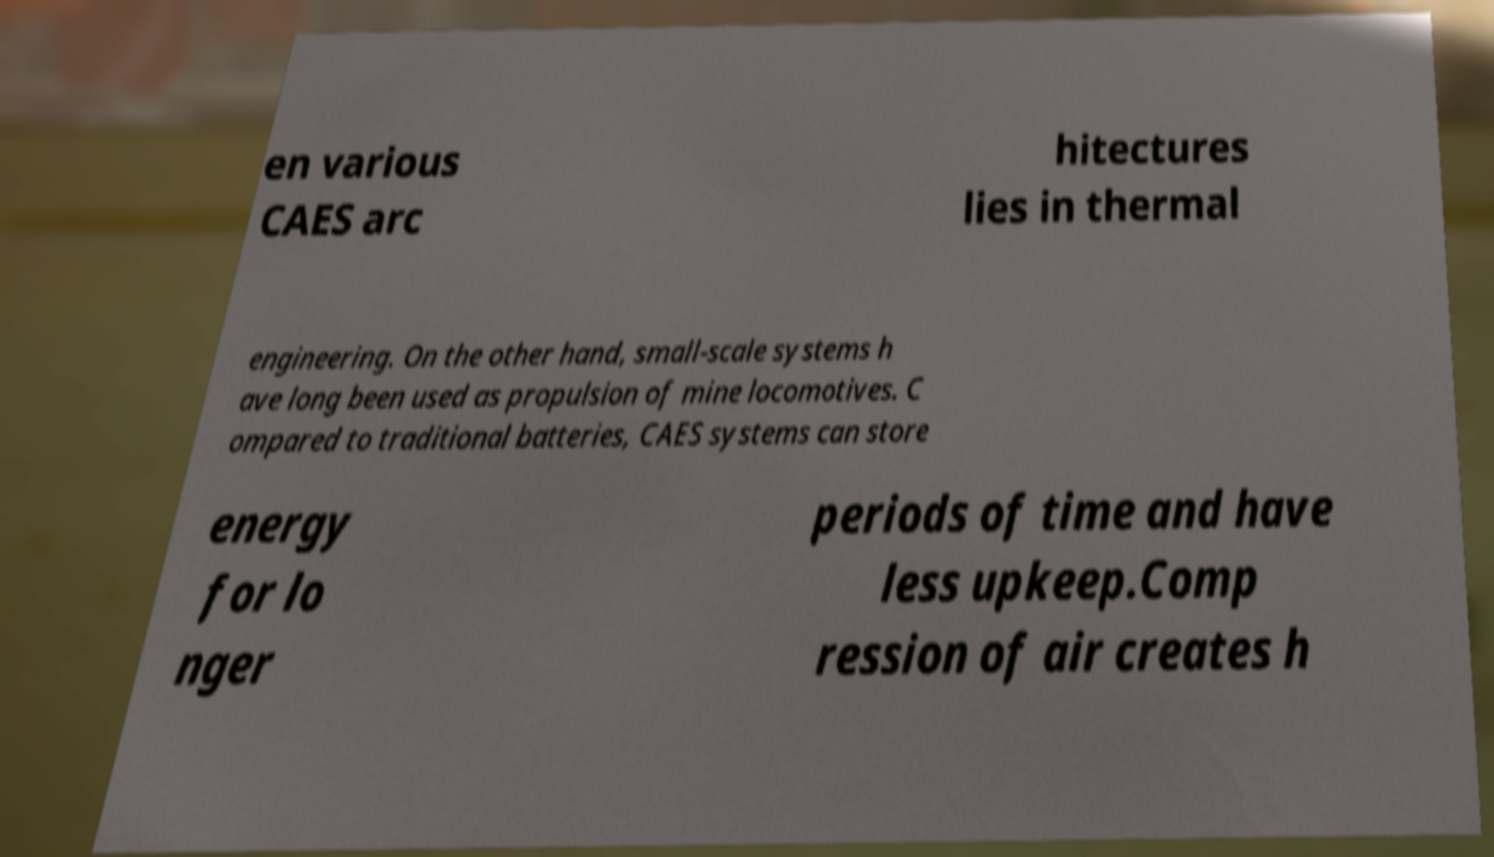Please identify and transcribe the text found in this image. en various CAES arc hitectures lies in thermal engineering. On the other hand, small-scale systems h ave long been used as propulsion of mine locomotives. C ompared to traditional batteries, CAES systems can store energy for lo nger periods of time and have less upkeep.Comp ression of air creates h 